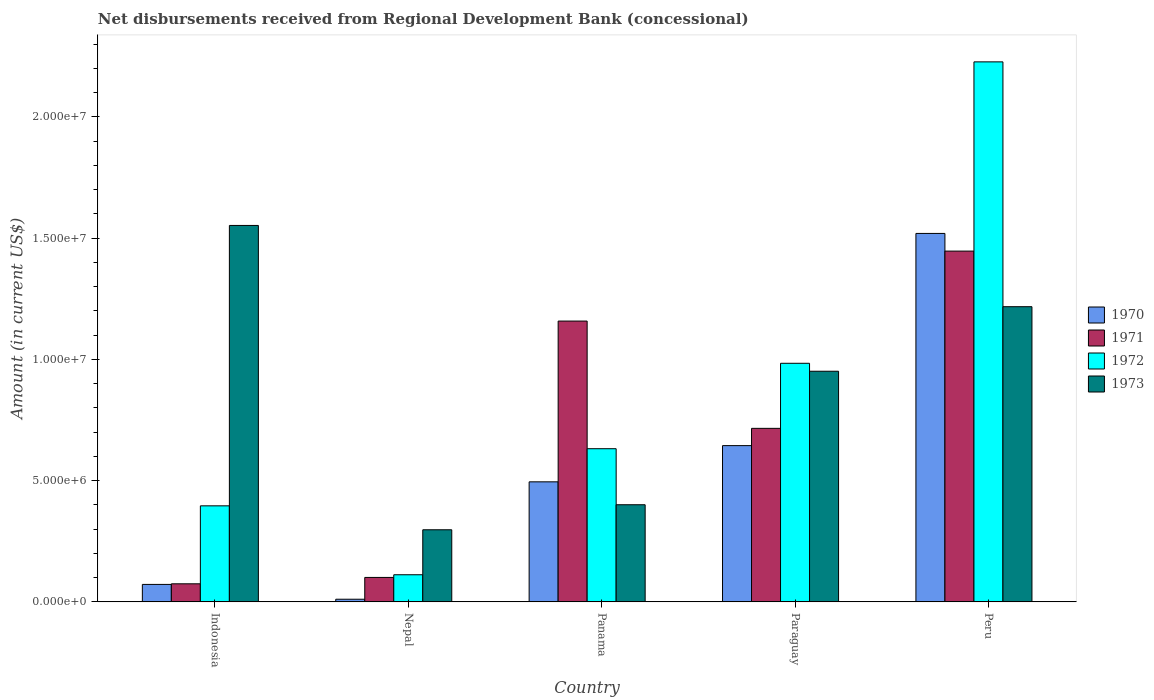Are the number of bars per tick equal to the number of legend labels?
Provide a succinct answer. Yes. How many bars are there on the 2nd tick from the right?
Provide a short and direct response. 4. What is the amount of disbursements received from Regional Development Bank in 1972 in Indonesia?
Your answer should be compact. 3.96e+06. Across all countries, what is the maximum amount of disbursements received from Regional Development Bank in 1972?
Provide a short and direct response. 2.23e+07. Across all countries, what is the minimum amount of disbursements received from Regional Development Bank in 1971?
Your answer should be compact. 7.45e+05. In which country was the amount of disbursements received from Regional Development Bank in 1972 maximum?
Your response must be concise. Peru. In which country was the amount of disbursements received from Regional Development Bank in 1972 minimum?
Provide a succinct answer. Nepal. What is the total amount of disbursements received from Regional Development Bank in 1972 in the graph?
Offer a very short reply. 4.35e+07. What is the difference between the amount of disbursements received from Regional Development Bank in 1972 in Indonesia and that in Panama?
Your answer should be very brief. -2.36e+06. What is the difference between the amount of disbursements received from Regional Development Bank in 1973 in Nepal and the amount of disbursements received from Regional Development Bank in 1970 in Peru?
Provide a succinct answer. -1.22e+07. What is the average amount of disbursements received from Regional Development Bank in 1973 per country?
Provide a short and direct response. 8.84e+06. What is the difference between the amount of disbursements received from Regional Development Bank of/in 1970 and amount of disbursements received from Regional Development Bank of/in 1973 in Panama?
Provide a short and direct response. 9.45e+05. In how many countries, is the amount of disbursements received from Regional Development Bank in 1971 greater than 12000000 US$?
Your response must be concise. 1. What is the ratio of the amount of disbursements received from Regional Development Bank in 1972 in Panama to that in Peru?
Your answer should be very brief. 0.28. What is the difference between the highest and the second highest amount of disbursements received from Regional Development Bank in 1970?
Your response must be concise. 1.02e+07. What is the difference between the highest and the lowest amount of disbursements received from Regional Development Bank in 1972?
Your response must be concise. 2.11e+07. In how many countries, is the amount of disbursements received from Regional Development Bank in 1972 greater than the average amount of disbursements received from Regional Development Bank in 1972 taken over all countries?
Your response must be concise. 2. Is it the case that in every country, the sum of the amount of disbursements received from Regional Development Bank in 1973 and amount of disbursements received from Regional Development Bank in 1972 is greater than the sum of amount of disbursements received from Regional Development Bank in 1970 and amount of disbursements received from Regional Development Bank in 1971?
Provide a short and direct response. No. What does the 3rd bar from the right in Peru represents?
Offer a terse response. 1971. How many countries are there in the graph?
Offer a terse response. 5. What is the difference between two consecutive major ticks on the Y-axis?
Your answer should be very brief. 5.00e+06. Does the graph contain any zero values?
Your answer should be very brief. No. Does the graph contain grids?
Offer a terse response. No. How many legend labels are there?
Ensure brevity in your answer.  4. What is the title of the graph?
Give a very brief answer. Net disbursements received from Regional Development Bank (concessional). What is the Amount (in current US$) of 1970 in Indonesia?
Offer a terse response. 7.20e+05. What is the Amount (in current US$) in 1971 in Indonesia?
Your response must be concise. 7.45e+05. What is the Amount (in current US$) of 1972 in Indonesia?
Offer a terse response. 3.96e+06. What is the Amount (in current US$) in 1973 in Indonesia?
Your answer should be compact. 1.55e+07. What is the Amount (in current US$) in 1970 in Nepal?
Ensure brevity in your answer.  1.09e+05. What is the Amount (in current US$) in 1971 in Nepal?
Offer a terse response. 1.01e+06. What is the Amount (in current US$) in 1972 in Nepal?
Your response must be concise. 1.12e+06. What is the Amount (in current US$) in 1973 in Nepal?
Provide a succinct answer. 2.97e+06. What is the Amount (in current US$) in 1970 in Panama?
Ensure brevity in your answer.  4.95e+06. What is the Amount (in current US$) of 1971 in Panama?
Provide a succinct answer. 1.16e+07. What is the Amount (in current US$) of 1972 in Panama?
Your answer should be compact. 6.32e+06. What is the Amount (in current US$) in 1973 in Panama?
Provide a succinct answer. 4.00e+06. What is the Amount (in current US$) in 1970 in Paraguay?
Make the answer very short. 6.44e+06. What is the Amount (in current US$) of 1971 in Paraguay?
Your response must be concise. 7.16e+06. What is the Amount (in current US$) of 1972 in Paraguay?
Make the answer very short. 9.84e+06. What is the Amount (in current US$) in 1973 in Paraguay?
Offer a very short reply. 9.51e+06. What is the Amount (in current US$) of 1970 in Peru?
Offer a very short reply. 1.52e+07. What is the Amount (in current US$) of 1971 in Peru?
Your answer should be compact. 1.45e+07. What is the Amount (in current US$) of 1972 in Peru?
Your answer should be very brief. 2.23e+07. What is the Amount (in current US$) in 1973 in Peru?
Ensure brevity in your answer.  1.22e+07. Across all countries, what is the maximum Amount (in current US$) in 1970?
Provide a short and direct response. 1.52e+07. Across all countries, what is the maximum Amount (in current US$) of 1971?
Provide a succinct answer. 1.45e+07. Across all countries, what is the maximum Amount (in current US$) of 1972?
Offer a terse response. 2.23e+07. Across all countries, what is the maximum Amount (in current US$) of 1973?
Offer a very short reply. 1.55e+07. Across all countries, what is the minimum Amount (in current US$) in 1970?
Make the answer very short. 1.09e+05. Across all countries, what is the minimum Amount (in current US$) in 1971?
Provide a short and direct response. 7.45e+05. Across all countries, what is the minimum Amount (in current US$) in 1972?
Offer a terse response. 1.12e+06. Across all countries, what is the minimum Amount (in current US$) in 1973?
Offer a terse response. 2.97e+06. What is the total Amount (in current US$) in 1970 in the graph?
Your response must be concise. 2.74e+07. What is the total Amount (in current US$) of 1971 in the graph?
Your answer should be very brief. 3.50e+07. What is the total Amount (in current US$) of 1972 in the graph?
Keep it short and to the point. 4.35e+07. What is the total Amount (in current US$) of 1973 in the graph?
Provide a succinct answer. 4.42e+07. What is the difference between the Amount (in current US$) of 1970 in Indonesia and that in Nepal?
Provide a short and direct response. 6.11e+05. What is the difference between the Amount (in current US$) in 1971 in Indonesia and that in Nepal?
Make the answer very short. -2.63e+05. What is the difference between the Amount (in current US$) in 1972 in Indonesia and that in Nepal?
Give a very brief answer. 2.84e+06. What is the difference between the Amount (in current US$) of 1973 in Indonesia and that in Nepal?
Your answer should be compact. 1.25e+07. What is the difference between the Amount (in current US$) of 1970 in Indonesia and that in Panama?
Offer a very short reply. -4.23e+06. What is the difference between the Amount (in current US$) in 1971 in Indonesia and that in Panama?
Offer a terse response. -1.08e+07. What is the difference between the Amount (in current US$) of 1972 in Indonesia and that in Panama?
Offer a very short reply. -2.36e+06. What is the difference between the Amount (in current US$) in 1973 in Indonesia and that in Panama?
Ensure brevity in your answer.  1.15e+07. What is the difference between the Amount (in current US$) of 1970 in Indonesia and that in Paraguay?
Your answer should be compact. -5.72e+06. What is the difference between the Amount (in current US$) of 1971 in Indonesia and that in Paraguay?
Your answer should be compact. -6.41e+06. What is the difference between the Amount (in current US$) of 1972 in Indonesia and that in Paraguay?
Keep it short and to the point. -5.88e+06. What is the difference between the Amount (in current US$) in 1973 in Indonesia and that in Paraguay?
Your response must be concise. 6.01e+06. What is the difference between the Amount (in current US$) of 1970 in Indonesia and that in Peru?
Your answer should be very brief. -1.45e+07. What is the difference between the Amount (in current US$) of 1971 in Indonesia and that in Peru?
Keep it short and to the point. -1.37e+07. What is the difference between the Amount (in current US$) in 1972 in Indonesia and that in Peru?
Provide a short and direct response. -1.83e+07. What is the difference between the Amount (in current US$) of 1973 in Indonesia and that in Peru?
Make the answer very short. 3.35e+06. What is the difference between the Amount (in current US$) in 1970 in Nepal and that in Panama?
Ensure brevity in your answer.  -4.84e+06. What is the difference between the Amount (in current US$) in 1971 in Nepal and that in Panama?
Provide a short and direct response. -1.06e+07. What is the difference between the Amount (in current US$) of 1972 in Nepal and that in Panama?
Offer a terse response. -5.20e+06. What is the difference between the Amount (in current US$) in 1973 in Nepal and that in Panama?
Provide a succinct answer. -1.03e+06. What is the difference between the Amount (in current US$) of 1970 in Nepal and that in Paraguay?
Keep it short and to the point. -6.33e+06. What is the difference between the Amount (in current US$) of 1971 in Nepal and that in Paraguay?
Offer a terse response. -6.15e+06. What is the difference between the Amount (in current US$) of 1972 in Nepal and that in Paraguay?
Your answer should be very brief. -8.72e+06. What is the difference between the Amount (in current US$) in 1973 in Nepal and that in Paraguay?
Offer a very short reply. -6.54e+06. What is the difference between the Amount (in current US$) of 1970 in Nepal and that in Peru?
Your answer should be very brief. -1.51e+07. What is the difference between the Amount (in current US$) of 1971 in Nepal and that in Peru?
Offer a very short reply. -1.35e+07. What is the difference between the Amount (in current US$) of 1972 in Nepal and that in Peru?
Offer a very short reply. -2.11e+07. What is the difference between the Amount (in current US$) in 1973 in Nepal and that in Peru?
Ensure brevity in your answer.  -9.20e+06. What is the difference between the Amount (in current US$) in 1970 in Panama and that in Paraguay?
Your response must be concise. -1.49e+06. What is the difference between the Amount (in current US$) of 1971 in Panama and that in Paraguay?
Provide a succinct answer. 4.42e+06. What is the difference between the Amount (in current US$) in 1972 in Panama and that in Paraguay?
Offer a terse response. -3.52e+06. What is the difference between the Amount (in current US$) of 1973 in Panama and that in Paraguay?
Offer a very short reply. -5.50e+06. What is the difference between the Amount (in current US$) of 1970 in Panama and that in Peru?
Make the answer very short. -1.02e+07. What is the difference between the Amount (in current US$) of 1971 in Panama and that in Peru?
Offer a very short reply. -2.88e+06. What is the difference between the Amount (in current US$) of 1972 in Panama and that in Peru?
Offer a terse response. -1.60e+07. What is the difference between the Amount (in current US$) in 1973 in Panama and that in Peru?
Your response must be concise. -8.17e+06. What is the difference between the Amount (in current US$) in 1970 in Paraguay and that in Peru?
Offer a terse response. -8.75e+06. What is the difference between the Amount (in current US$) of 1971 in Paraguay and that in Peru?
Your answer should be compact. -7.31e+06. What is the difference between the Amount (in current US$) of 1972 in Paraguay and that in Peru?
Provide a succinct answer. -1.24e+07. What is the difference between the Amount (in current US$) in 1973 in Paraguay and that in Peru?
Give a very brief answer. -2.66e+06. What is the difference between the Amount (in current US$) in 1970 in Indonesia and the Amount (in current US$) in 1971 in Nepal?
Offer a terse response. -2.88e+05. What is the difference between the Amount (in current US$) of 1970 in Indonesia and the Amount (in current US$) of 1972 in Nepal?
Offer a terse response. -3.98e+05. What is the difference between the Amount (in current US$) of 1970 in Indonesia and the Amount (in current US$) of 1973 in Nepal?
Give a very brief answer. -2.25e+06. What is the difference between the Amount (in current US$) in 1971 in Indonesia and the Amount (in current US$) in 1972 in Nepal?
Keep it short and to the point. -3.73e+05. What is the difference between the Amount (in current US$) in 1971 in Indonesia and the Amount (in current US$) in 1973 in Nepal?
Your answer should be compact. -2.23e+06. What is the difference between the Amount (in current US$) of 1972 in Indonesia and the Amount (in current US$) of 1973 in Nepal?
Your response must be concise. 9.87e+05. What is the difference between the Amount (in current US$) of 1970 in Indonesia and the Amount (in current US$) of 1971 in Panama?
Provide a short and direct response. -1.09e+07. What is the difference between the Amount (in current US$) of 1970 in Indonesia and the Amount (in current US$) of 1972 in Panama?
Provide a succinct answer. -5.60e+06. What is the difference between the Amount (in current US$) of 1970 in Indonesia and the Amount (in current US$) of 1973 in Panama?
Your response must be concise. -3.28e+06. What is the difference between the Amount (in current US$) of 1971 in Indonesia and the Amount (in current US$) of 1972 in Panama?
Keep it short and to the point. -5.57e+06. What is the difference between the Amount (in current US$) in 1971 in Indonesia and the Amount (in current US$) in 1973 in Panama?
Your answer should be very brief. -3.26e+06. What is the difference between the Amount (in current US$) in 1972 in Indonesia and the Amount (in current US$) in 1973 in Panama?
Your answer should be very brief. -4.50e+04. What is the difference between the Amount (in current US$) of 1970 in Indonesia and the Amount (in current US$) of 1971 in Paraguay?
Provide a short and direct response. -6.44e+06. What is the difference between the Amount (in current US$) of 1970 in Indonesia and the Amount (in current US$) of 1972 in Paraguay?
Ensure brevity in your answer.  -9.12e+06. What is the difference between the Amount (in current US$) of 1970 in Indonesia and the Amount (in current US$) of 1973 in Paraguay?
Offer a terse response. -8.79e+06. What is the difference between the Amount (in current US$) in 1971 in Indonesia and the Amount (in current US$) in 1972 in Paraguay?
Provide a succinct answer. -9.09e+06. What is the difference between the Amount (in current US$) of 1971 in Indonesia and the Amount (in current US$) of 1973 in Paraguay?
Provide a succinct answer. -8.76e+06. What is the difference between the Amount (in current US$) in 1972 in Indonesia and the Amount (in current US$) in 1973 in Paraguay?
Offer a terse response. -5.55e+06. What is the difference between the Amount (in current US$) of 1970 in Indonesia and the Amount (in current US$) of 1971 in Peru?
Provide a succinct answer. -1.37e+07. What is the difference between the Amount (in current US$) in 1970 in Indonesia and the Amount (in current US$) in 1972 in Peru?
Provide a succinct answer. -2.15e+07. What is the difference between the Amount (in current US$) of 1970 in Indonesia and the Amount (in current US$) of 1973 in Peru?
Ensure brevity in your answer.  -1.15e+07. What is the difference between the Amount (in current US$) of 1971 in Indonesia and the Amount (in current US$) of 1972 in Peru?
Make the answer very short. -2.15e+07. What is the difference between the Amount (in current US$) of 1971 in Indonesia and the Amount (in current US$) of 1973 in Peru?
Give a very brief answer. -1.14e+07. What is the difference between the Amount (in current US$) in 1972 in Indonesia and the Amount (in current US$) in 1973 in Peru?
Provide a short and direct response. -8.21e+06. What is the difference between the Amount (in current US$) in 1970 in Nepal and the Amount (in current US$) in 1971 in Panama?
Offer a terse response. -1.15e+07. What is the difference between the Amount (in current US$) in 1970 in Nepal and the Amount (in current US$) in 1972 in Panama?
Provide a short and direct response. -6.21e+06. What is the difference between the Amount (in current US$) of 1970 in Nepal and the Amount (in current US$) of 1973 in Panama?
Make the answer very short. -3.90e+06. What is the difference between the Amount (in current US$) in 1971 in Nepal and the Amount (in current US$) in 1972 in Panama?
Your answer should be compact. -5.31e+06. What is the difference between the Amount (in current US$) in 1971 in Nepal and the Amount (in current US$) in 1973 in Panama?
Your answer should be compact. -3.00e+06. What is the difference between the Amount (in current US$) in 1972 in Nepal and the Amount (in current US$) in 1973 in Panama?
Give a very brief answer. -2.89e+06. What is the difference between the Amount (in current US$) in 1970 in Nepal and the Amount (in current US$) in 1971 in Paraguay?
Your answer should be very brief. -7.05e+06. What is the difference between the Amount (in current US$) of 1970 in Nepal and the Amount (in current US$) of 1972 in Paraguay?
Provide a succinct answer. -9.73e+06. What is the difference between the Amount (in current US$) in 1970 in Nepal and the Amount (in current US$) in 1973 in Paraguay?
Provide a short and direct response. -9.40e+06. What is the difference between the Amount (in current US$) of 1971 in Nepal and the Amount (in current US$) of 1972 in Paraguay?
Your answer should be compact. -8.83e+06. What is the difference between the Amount (in current US$) in 1971 in Nepal and the Amount (in current US$) in 1973 in Paraguay?
Provide a succinct answer. -8.50e+06. What is the difference between the Amount (in current US$) in 1972 in Nepal and the Amount (in current US$) in 1973 in Paraguay?
Give a very brief answer. -8.39e+06. What is the difference between the Amount (in current US$) in 1970 in Nepal and the Amount (in current US$) in 1971 in Peru?
Offer a terse response. -1.44e+07. What is the difference between the Amount (in current US$) of 1970 in Nepal and the Amount (in current US$) of 1972 in Peru?
Your answer should be very brief. -2.22e+07. What is the difference between the Amount (in current US$) in 1970 in Nepal and the Amount (in current US$) in 1973 in Peru?
Provide a succinct answer. -1.21e+07. What is the difference between the Amount (in current US$) of 1971 in Nepal and the Amount (in current US$) of 1972 in Peru?
Your response must be concise. -2.13e+07. What is the difference between the Amount (in current US$) of 1971 in Nepal and the Amount (in current US$) of 1973 in Peru?
Offer a terse response. -1.12e+07. What is the difference between the Amount (in current US$) in 1972 in Nepal and the Amount (in current US$) in 1973 in Peru?
Ensure brevity in your answer.  -1.11e+07. What is the difference between the Amount (in current US$) of 1970 in Panama and the Amount (in current US$) of 1971 in Paraguay?
Provide a succinct answer. -2.20e+06. What is the difference between the Amount (in current US$) in 1970 in Panama and the Amount (in current US$) in 1972 in Paraguay?
Your answer should be very brief. -4.89e+06. What is the difference between the Amount (in current US$) of 1970 in Panama and the Amount (in current US$) of 1973 in Paraguay?
Provide a succinct answer. -4.56e+06. What is the difference between the Amount (in current US$) in 1971 in Panama and the Amount (in current US$) in 1972 in Paraguay?
Ensure brevity in your answer.  1.74e+06. What is the difference between the Amount (in current US$) in 1971 in Panama and the Amount (in current US$) in 1973 in Paraguay?
Your response must be concise. 2.07e+06. What is the difference between the Amount (in current US$) of 1972 in Panama and the Amount (in current US$) of 1973 in Paraguay?
Give a very brief answer. -3.19e+06. What is the difference between the Amount (in current US$) of 1970 in Panama and the Amount (in current US$) of 1971 in Peru?
Your response must be concise. -9.51e+06. What is the difference between the Amount (in current US$) in 1970 in Panama and the Amount (in current US$) in 1972 in Peru?
Your answer should be very brief. -1.73e+07. What is the difference between the Amount (in current US$) of 1970 in Panama and the Amount (in current US$) of 1973 in Peru?
Provide a succinct answer. -7.22e+06. What is the difference between the Amount (in current US$) in 1971 in Panama and the Amount (in current US$) in 1972 in Peru?
Offer a terse response. -1.07e+07. What is the difference between the Amount (in current US$) of 1971 in Panama and the Amount (in current US$) of 1973 in Peru?
Provide a short and direct response. -5.93e+05. What is the difference between the Amount (in current US$) in 1972 in Panama and the Amount (in current US$) in 1973 in Peru?
Offer a very short reply. -5.86e+06. What is the difference between the Amount (in current US$) in 1970 in Paraguay and the Amount (in current US$) in 1971 in Peru?
Keep it short and to the point. -8.02e+06. What is the difference between the Amount (in current US$) of 1970 in Paraguay and the Amount (in current US$) of 1972 in Peru?
Your answer should be compact. -1.58e+07. What is the difference between the Amount (in current US$) in 1970 in Paraguay and the Amount (in current US$) in 1973 in Peru?
Keep it short and to the point. -5.73e+06. What is the difference between the Amount (in current US$) in 1971 in Paraguay and the Amount (in current US$) in 1972 in Peru?
Provide a succinct answer. -1.51e+07. What is the difference between the Amount (in current US$) in 1971 in Paraguay and the Amount (in current US$) in 1973 in Peru?
Provide a short and direct response. -5.02e+06. What is the difference between the Amount (in current US$) in 1972 in Paraguay and the Amount (in current US$) in 1973 in Peru?
Your answer should be compact. -2.33e+06. What is the average Amount (in current US$) of 1970 per country?
Provide a short and direct response. 5.48e+06. What is the average Amount (in current US$) of 1971 per country?
Keep it short and to the point. 6.99e+06. What is the average Amount (in current US$) in 1972 per country?
Give a very brief answer. 8.70e+06. What is the average Amount (in current US$) in 1973 per country?
Offer a very short reply. 8.84e+06. What is the difference between the Amount (in current US$) of 1970 and Amount (in current US$) of 1971 in Indonesia?
Your answer should be very brief. -2.50e+04. What is the difference between the Amount (in current US$) of 1970 and Amount (in current US$) of 1972 in Indonesia?
Ensure brevity in your answer.  -3.24e+06. What is the difference between the Amount (in current US$) of 1970 and Amount (in current US$) of 1973 in Indonesia?
Your answer should be compact. -1.48e+07. What is the difference between the Amount (in current US$) in 1971 and Amount (in current US$) in 1972 in Indonesia?
Give a very brief answer. -3.22e+06. What is the difference between the Amount (in current US$) of 1971 and Amount (in current US$) of 1973 in Indonesia?
Offer a terse response. -1.48e+07. What is the difference between the Amount (in current US$) in 1972 and Amount (in current US$) in 1973 in Indonesia?
Provide a short and direct response. -1.16e+07. What is the difference between the Amount (in current US$) of 1970 and Amount (in current US$) of 1971 in Nepal?
Your response must be concise. -8.99e+05. What is the difference between the Amount (in current US$) in 1970 and Amount (in current US$) in 1972 in Nepal?
Provide a succinct answer. -1.01e+06. What is the difference between the Amount (in current US$) in 1970 and Amount (in current US$) in 1973 in Nepal?
Offer a very short reply. -2.86e+06. What is the difference between the Amount (in current US$) of 1971 and Amount (in current US$) of 1972 in Nepal?
Make the answer very short. -1.10e+05. What is the difference between the Amount (in current US$) in 1971 and Amount (in current US$) in 1973 in Nepal?
Your answer should be very brief. -1.96e+06. What is the difference between the Amount (in current US$) of 1972 and Amount (in current US$) of 1973 in Nepal?
Keep it short and to the point. -1.86e+06. What is the difference between the Amount (in current US$) of 1970 and Amount (in current US$) of 1971 in Panama?
Offer a very short reply. -6.63e+06. What is the difference between the Amount (in current US$) of 1970 and Amount (in current US$) of 1972 in Panama?
Provide a short and direct response. -1.37e+06. What is the difference between the Amount (in current US$) in 1970 and Amount (in current US$) in 1973 in Panama?
Provide a short and direct response. 9.45e+05. What is the difference between the Amount (in current US$) in 1971 and Amount (in current US$) in 1972 in Panama?
Make the answer very short. 5.26e+06. What is the difference between the Amount (in current US$) in 1971 and Amount (in current US$) in 1973 in Panama?
Make the answer very short. 7.57e+06. What is the difference between the Amount (in current US$) in 1972 and Amount (in current US$) in 1973 in Panama?
Provide a short and direct response. 2.31e+06. What is the difference between the Amount (in current US$) of 1970 and Amount (in current US$) of 1971 in Paraguay?
Ensure brevity in your answer.  -7.12e+05. What is the difference between the Amount (in current US$) of 1970 and Amount (in current US$) of 1972 in Paraguay?
Your response must be concise. -3.40e+06. What is the difference between the Amount (in current US$) of 1970 and Amount (in current US$) of 1973 in Paraguay?
Keep it short and to the point. -3.07e+06. What is the difference between the Amount (in current US$) in 1971 and Amount (in current US$) in 1972 in Paraguay?
Your answer should be compact. -2.68e+06. What is the difference between the Amount (in current US$) in 1971 and Amount (in current US$) in 1973 in Paraguay?
Provide a short and direct response. -2.36e+06. What is the difference between the Amount (in current US$) of 1972 and Amount (in current US$) of 1973 in Paraguay?
Ensure brevity in your answer.  3.28e+05. What is the difference between the Amount (in current US$) of 1970 and Amount (in current US$) of 1971 in Peru?
Provide a succinct answer. 7.29e+05. What is the difference between the Amount (in current US$) in 1970 and Amount (in current US$) in 1972 in Peru?
Your answer should be very brief. -7.07e+06. What is the difference between the Amount (in current US$) of 1970 and Amount (in current US$) of 1973 in Peru?
Make the answer very short. 3.02e+06. What is the difference between the Amount (in current US$) in 1971 and Amount (in current US$) in 1972 in Peru?
Your answer should be compact. -7.80e+06. What is the difference between the Amount (in current US$) of 1971 and Amount (in current US$) of 1973 in Peru?
Keep it short and to the point. 2.29e+06. What is the difference between the Amount (in current US$) of 1972 and Amount (in current US$) of 1973 in Peru?
Make the answer very short. 1.01e+07. What is the ratio of the Amount (in current US$) in 1970 in Indonesia to that in Nepal?
Offer a terse response. 6.61. What is the ratio of the Amount (in current US$) in 1971 in Indonesia to that in Nepal?
Provide a succinct answer. 0.74. What is the ratio of the Amount (in current US$) in 1972 in Indonesia to that in Nepal?
Provide a succinct answer. 3.54. What is the ratio of the Amount (in current US$) of 1973 in Indonesia to that in Nepal?
Your response must be concise. 5.22. What is the ratio of the Amount (in current US$) of 1970 in Indonesia to that in Panama?
Give a very brief answer. 0.15. What is the ratio of the Amount (in current US$) in 1971 in Indonesia to that in Panama?
Ensure brevity in your answer.  0.06. What is the ratio of the Amount (in current US$) of 1972 in Indonesia to that in Panama?
Offer a very short reply. 0.63. What is the ratio of the Amount (in current US$) of 1973 in Indonesia to that in Panama?
Make the answer very short. 3.88. What is the ratio of the Amount (in current US$) of 1970 in Indonesia to that in Paraguay?
Offer a very short reply. 0.11. What is the ratio of the Amount (in current US$) of 1971 in Indonesia to that in Paraguay?
Make the answer very short. 0.1. What is the ratio of the Amount (in current US$) in 1972 in Indonesia to that in Paraguay?
Keep it short and to the point. 0.4. What is the ratio of the Amount (in current US$) in 1973 in Indonesia to that in Paraguay?
Your answer should be compact. 1.63. What is the ratio of the Amount (in current US$) of 1970 in Indonesia to that in Peru?
Give a very brief answer. 0.05. What is the ratio of the Amount (in current US$) in 1971 in Indonesia to that in Peru?
Keep it short and to the point. 0.05. What is the ratio of the Amount (in current US$) in 1972 in Indonesia to that in Peru?
Your answer should be very brief. 0.18. What is the ratio of the Amount (in current US$) of 1973 in Indonesia to that in Peru?
Your answer should be very brief. 1.28. What is the ratio of the Amount (in current US$) in 1970 in Nepal to that in Panama?
Keep it short and to the point. 0.02. What is the ratio of the Amount (in current US$) in 1971 in Nepal to that in Panama?
Your response must be concise. 0.09. What is the ratio of the Amount (in current US$) of 1972 in Nepal to that in Panama?
Your answer should be compact. 0.18. What is the ratio of the Amount (in current US$) of 1973 in Nepal to that in Panama?
Your answer should be very brief. 0.74. What is the ratio of the Amount (in current US$) of 1970 in Nepal to that in Paraguay?
Your answer should be very brief. 0.02. What is the ratio of the Amount (in current US$) in 1971 in Nepal to that in Paraguay?
Your response must be concise. 0.14. What is the ratio of the Amount (in current US$) in 1972 in Nepal to that in Paraguay?
Ensure brevity in your answer.  0.11. What is the ratio of the Amount (in current US$) of 1973 in Nepal to that in Paraguay?
Your response must be concise. 0.31. What is the ratio of the Amount (in current US$) in 1970 in Nepal to that in Peru?
Provide a succinct answer. 0.01. What is the ratio of the Amount (in current US$) of 1971 in Nepal to that in Peru?
Your answer should be very brief. 0.07. What is the ratio of the Amount (in current US$) of 1972 in Nepal to that in Peru?
Offer a very short reply. 0.05. What is the ratio of the Amount (in current US$) in 1973 in Nepal to that in Peru?
Keep it short and to the point. 0.24. What is the ratio of the Amount (in current US$) of 1970 in Panama to that in Paraguay?
Provide a short and direct response. 0.77. What is the ratio of the Amount (in current US$) in 1971 in Panama to that in Paraguay?
Offer a terse response. 1.62. What is the ratio of the Amount (in current US$) of 1972 in Panama to that in Paraguay?
Your answer should be compact. 0.64. What is the ratio of the Amount (in current US$) of 1973 in Panama to that in Paraguay?
Keep it short and to the point. 0.42. What is the ratio of the Amount (in current US$) in 1970 in Panama to that in Peru?
Your response must be concise. 0.33. What is the ratio of the Amount (in current US$) in 1971 in Panama to that in Peru?
Give a very brief answer. 0.8. What is the ratio of the Amount (in current US$) in 1972 in Panama to that in Peru?
Provide a short and direct response. 0.28. What is the ratio of the Amount (in current US$) of 1973 in Panama to that in Peru?
Your response must be concise. 0.33. What is the ratio of the Amount (in current US$) in 1970 in Paraguay to that in Peru?
Provide a short and direct response. 0.42. What is the ratio of the Amount (in current US$) in 1971 in Paraguay to that in Peru?
Ensure brevity in your answer.  0.49. What is the ratio of the Amount (in current US$) of 1972 in Paraguay to that in Peru?
Provide a short and direct response. 0.44. What is the ratio of the Amount (in current US$) in 1973 in Paraguay to that in Peru?
Offer a terse response. 0.78. What is the difference between the highest and the second highest Amount (in current US$) in 1970?
Your answer should be compact. 8.75e+06. What is the difference between the highest and the second highest Amount (in current US$) in 1971?
Offer a terse response. 2.88e+06. What is the difference between the highest and the second highest Amount (in current US$) of 1972?
Your answer should be very brief. 1.24e+07. What is the difference between the highest and the second highest Amount (in current US$) of 1973?
Offer a terse response. 3.35e+06. What is the difference between the highest and the lowest Amount (in current US$) of 1970?
Provide a short and direct response. 1.51e+07. What is the difference between the highest and the lowest Amount (in current US$) of 1971?
Ensure brevity in your answer.  1.37e+07. What is the difference between the highest and the lowest Amount (in current US$) of 1972?
Offer a terse response. 2.11e+07. What is the difference between the highest and the lowest Amount (in current US$) in 1973?
Your answer should be compact. 1.25e+07. 